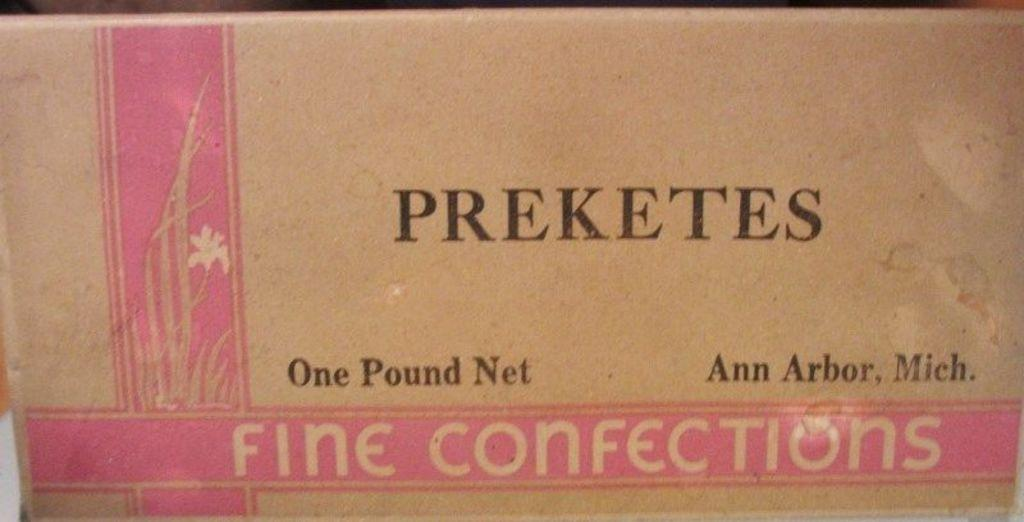Provide a one-sentence caption for the provided image. a close up of Fine Confections from Preketes. 